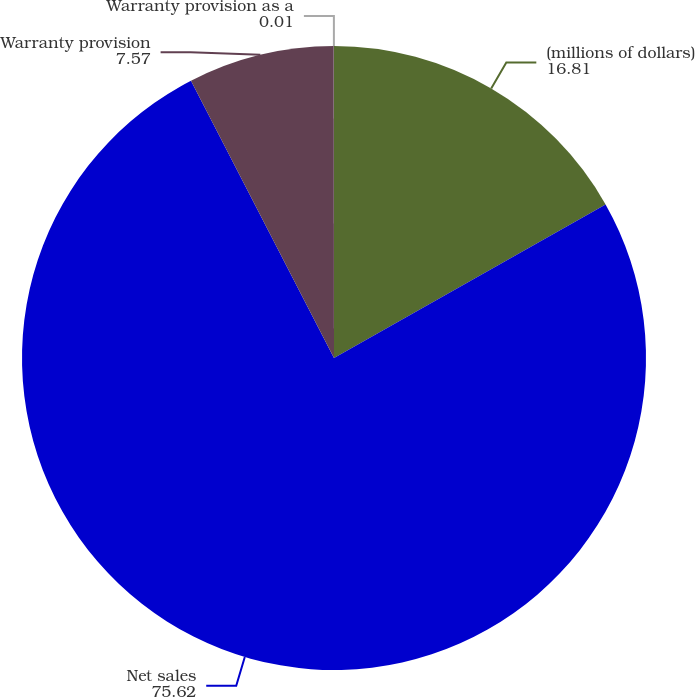Convert chart. <chart><loc_0><loc_0><loc_500><loc_500><pie_chart><fcel>(millions of dollars)<fcel>Net sales<fcel>Warranty provision<fcel>Warranty provision as a<nl><fcel>16.81%<fcel>75.62%<fcel>7.57%<fcel>0.01%<nl></chart> 